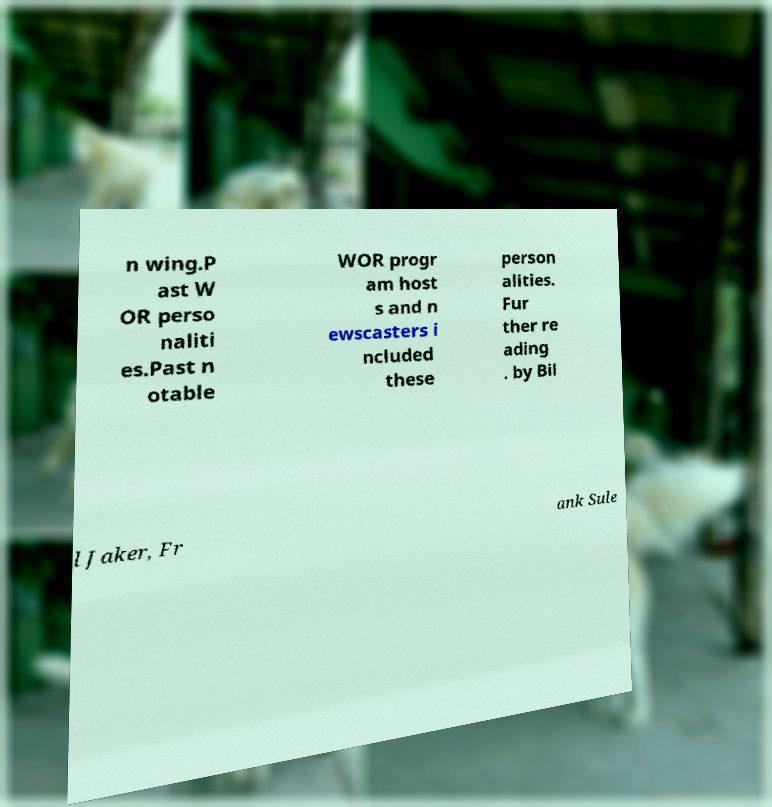Could you assist in decoding the text presented in this image and type it out clearly? n wing.P ast W OR perso naliti es.Past n otable WOR progr am host s and n ewscasters i ncluded these person alities. Fur ther re ading . by Bil l Jaker, Fr ank Sule 